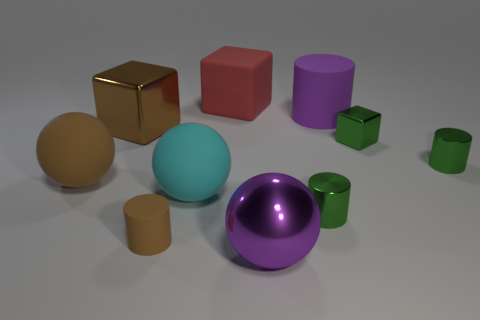Subtract all large purple spheres. How many spheres are left? 2 Subtract all cyan spheres. How many spheres are left? 2 Subtract 2 balls. How many balls are left? 1 Subtract all cylinders. How many objects are left? 6 Subtract all gray blocks. How many purple spheres are left? 1 Subtract all brown balls. Subtract all green cylinders. How many balls are left? 2 Subtract all big brown things. Subtract all brown objects. How many objects are left? 5 Add 8 purple spheres. How many purple spheres are left? 9 Add 1 large rubber spheres. How many large rubber spheres exist? 3 Subtract 0 blue spheres. How many objects are left? 10 